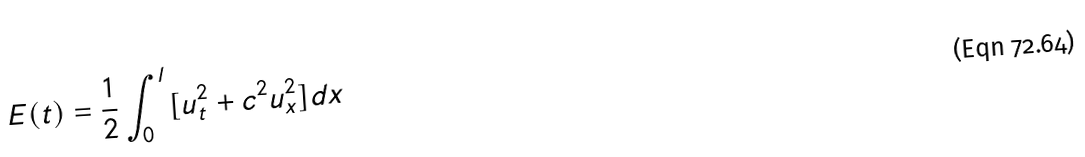<formula> <loc_0><loc_0><loc_500><loc_500>E ( t ) = \frac { 1 } { 2 } \int _ { 0 } ^ { l } [ u _ { t } ^ { 2 } + c ^ { 2 } u _ { x } ^ { 2 } ] d x</formula> 